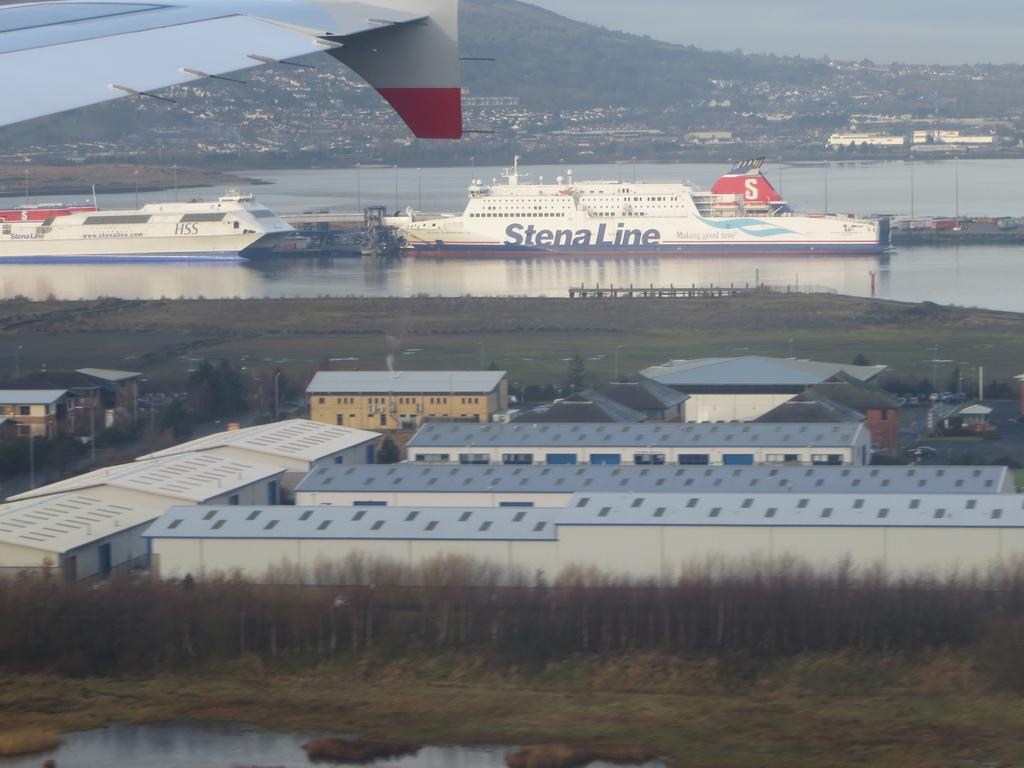<image>
Summarize the visual content of the image. A Stena Line cruise ship waits at the docks. 